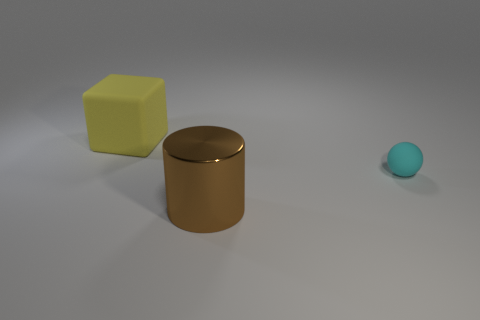Are any blue rubber blocks visible?
Keep it short and to the point. No. Is there a large red thing that has the same material as the yellow thing?
Make the answer very short. No. Do the object that is behind the cyan ball and the sphere have the same material?
Your response must be concise. Yes. Are there more small cyan rubber objects in front of the yellow object than cubes that are to the right of the big brown shiny object?
Give a very brief answer. Yes. What color is the rubber object that is the same size as the shiny cylinder?
Your response must be concise. Yellow. There is a big thing to the left of the large brown cylinder; what is its material?
Keep it short and to the point. Rubber. What is the color of the small sphere that is the same material as the block?
Ensure brevity in your answer.  Cyan. How many brown metal cylinders have the same size as the yellow rubber object?
Keep it short and to the point. 1. Is the size of the rubber object that is in front of the yellow block the same as the metallic object?
Give a very brief answer. No. There is a object that is behind the metallic cylinder and left of the matte ball; what shape is it?
Your answer should be very brief. Cube. 